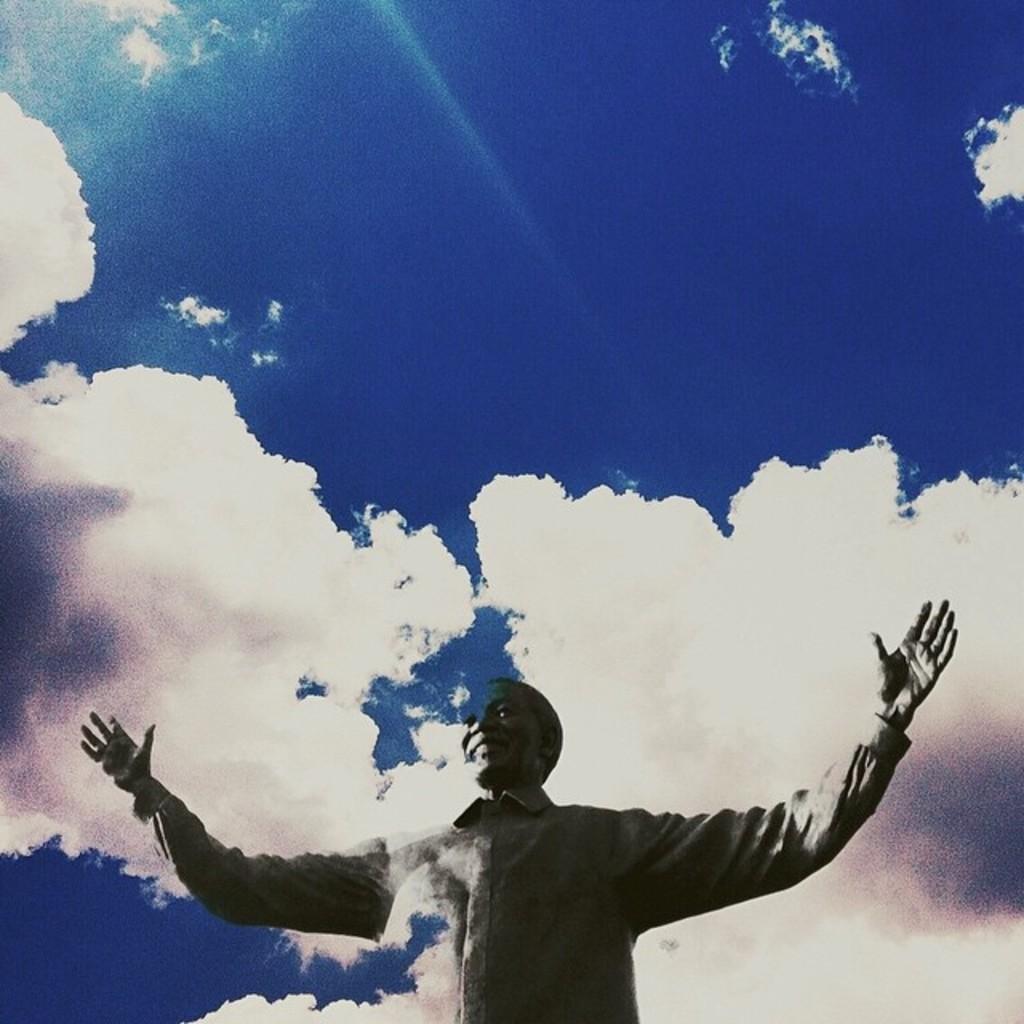Describe this image in one or two sentences. This is an edited image. In this image I can see the person with the dress. In the background I can see the clouds and the sky. 